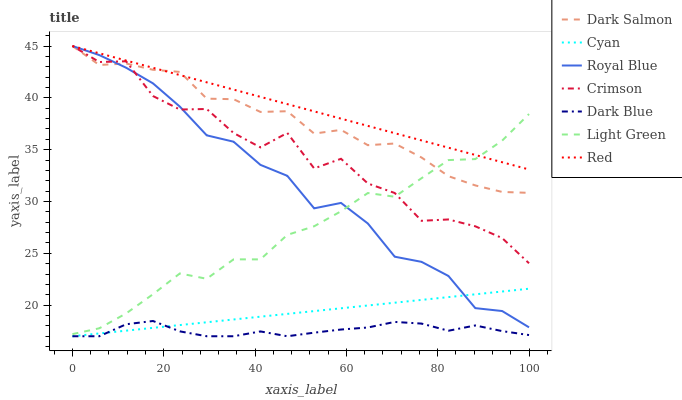Does Dark Blue have the minimum area under the curve?
Answer yes or no. Yes. Does Red have the maximum area under the curve?
Answer yes or no. Yes. Does Dark Salmon have the minimum area under the curve?
Answer yes or no. No. Does Dark Salmon have the maximum area under the curve?
Answer yes or no. No. Is Red the smoothest?
Answer yes or no. Yes. Is Crimson the roughest?
Answer yes or no. Yes. Is Dark Salmon the smoothest?
Answer yes or no. No. Is Dark Salmon the roughest?
Answer yes or no. No. Does Dark Blue have the lowest value?
Answer yes or no. Yes. Does Dark Salmon have the lowest value?
Answer yes or no. No. Does Red have the highest value?
Answer yes or no. Yes. Does Dark Blue have the highest value?
Answer yes or no. No. Is Dark Blue less than Dark Salmon?
Answer yes or no. Yes. Is Royal Blue greater than Dark Blue?
Answer yes or no. Yes. Does Red intersect Dark Salmon?
Answer yes or no. Yes. Is Red less than Dark Salmon?
Answer yes or no. No. Is Red greater than Dark Salmon?
Answer yes or no. No. Does Dark Blue intersect Dark Salmon?
Answer yes or no. No. 